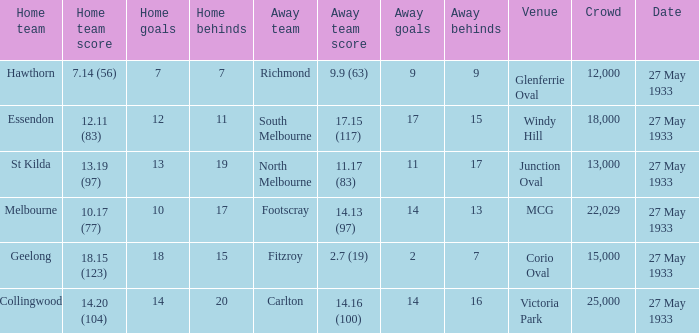In the match where the away team scored 2.7 (19), how many peopel were in the crowd? 15000.0. 